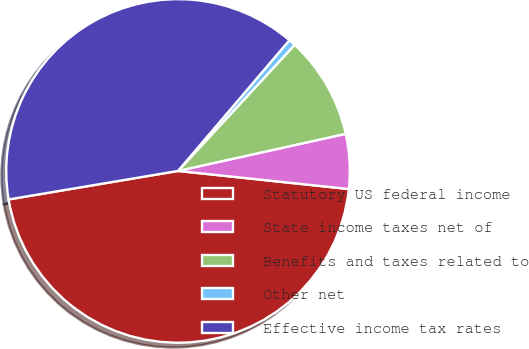Convert chart to OTSL. <chart><loc_0><loc_0><loc_500><loc_500><pie_chart><fcel>Statutory US federal income<fcel>State income taxes net of<fcel>Benefits and taxes related to<fcel>Other net<fcel>Effective income tax rates<nl><fcel>45.66%<fcel>5.15%<fcel>9.65%<fcel>0.65%<fcel>38.88%<nl></chart> 